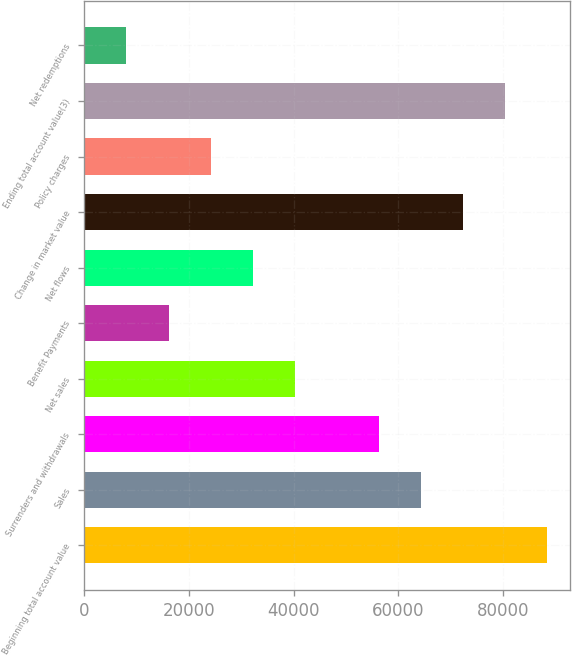<chart> <loc_0><loc_0><loc_500><loc_500><bar_chart><fcel>Beginning total account value<fcel>Sales<fcel>Surrenders and withdrawals<fcel>Net sales<fcel>Benefit Payments<fcel>Net flows<fcel>Change in market value<fcel>Policy charges<fcel>Ending total account value(3)<fcel>Net redemptions<nl><fcel>88350.3<fcel>64289.4<fcel>56269.1<fcel>40228.5<fcel>16167.6<fcel>32208.2<fcel>72309.7<fcel>24187.9<fcel>80330<fcel>8147.3<nl></chart> 